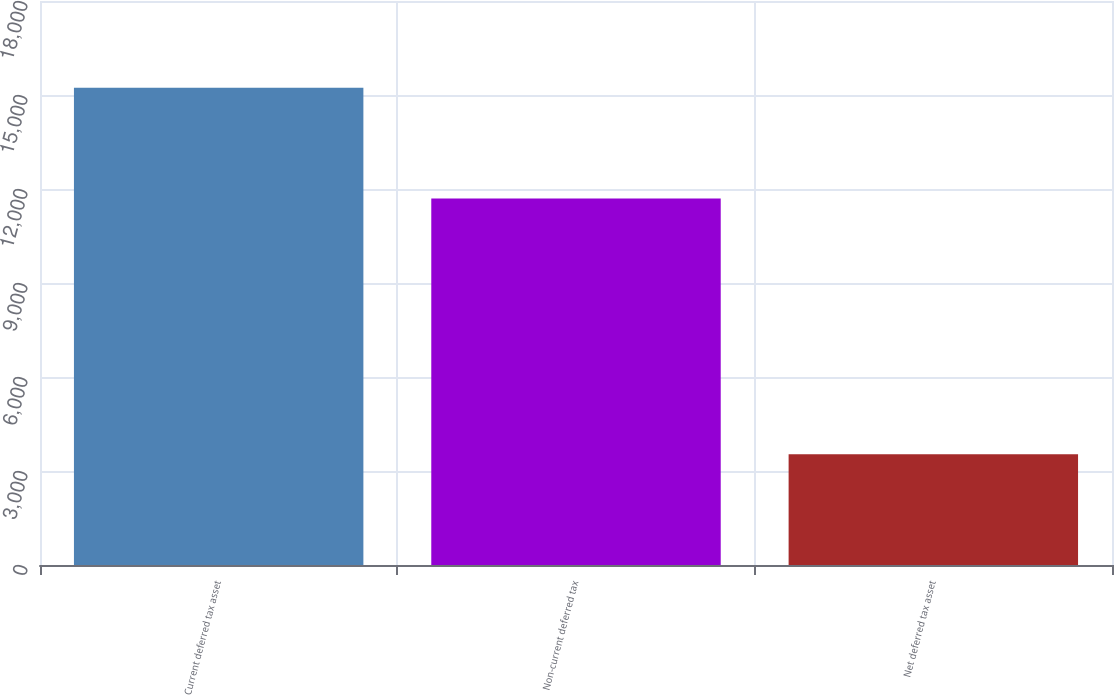<chart> <loc_0><loc_0><loc_500><loc_500><bar_chart><fcel>Current deferred tax asset<fcel>Non-current deferred tax<fcel>Net deferred tax asset<nl><fcel>15230<fcel>11695<fcel>3535<nl></chart> 